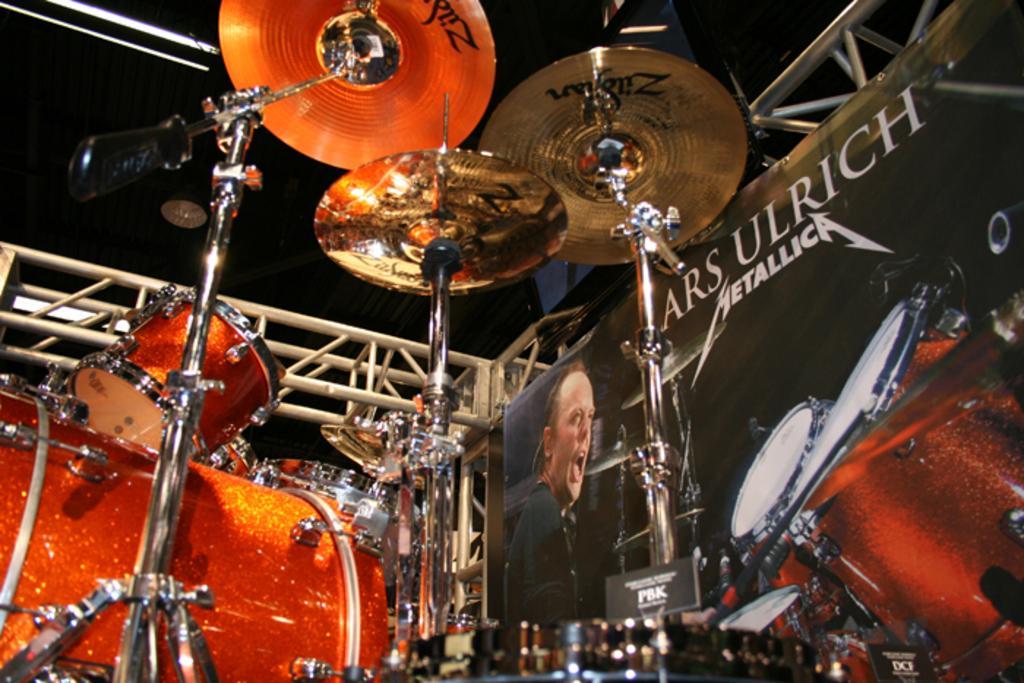Can you describe this image briefly? In this image, I can see the drums and cymbals with stands. On the right side of the image, I can see a banner with the photos of a person, drums, cymbals and words. There are trusses. 